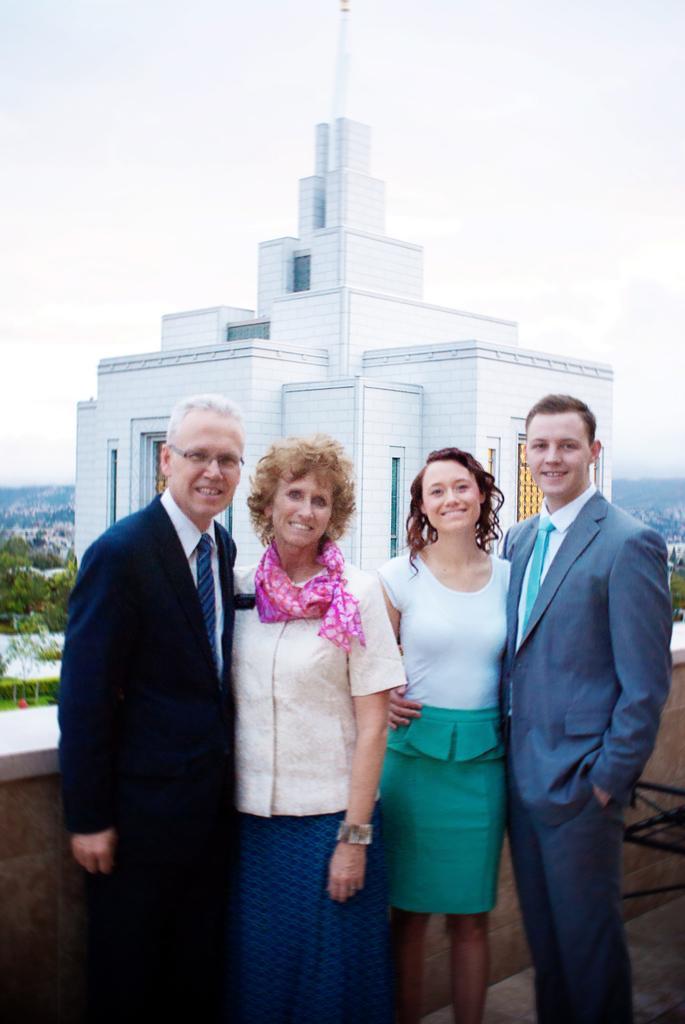Can you describe this image briefly? In the middle of the image four persons are standing and smiling. Behind them we can see a wall. In the middle of the image we can see some trees and buildings. At the top of the image we can see some clouds in the sky. 